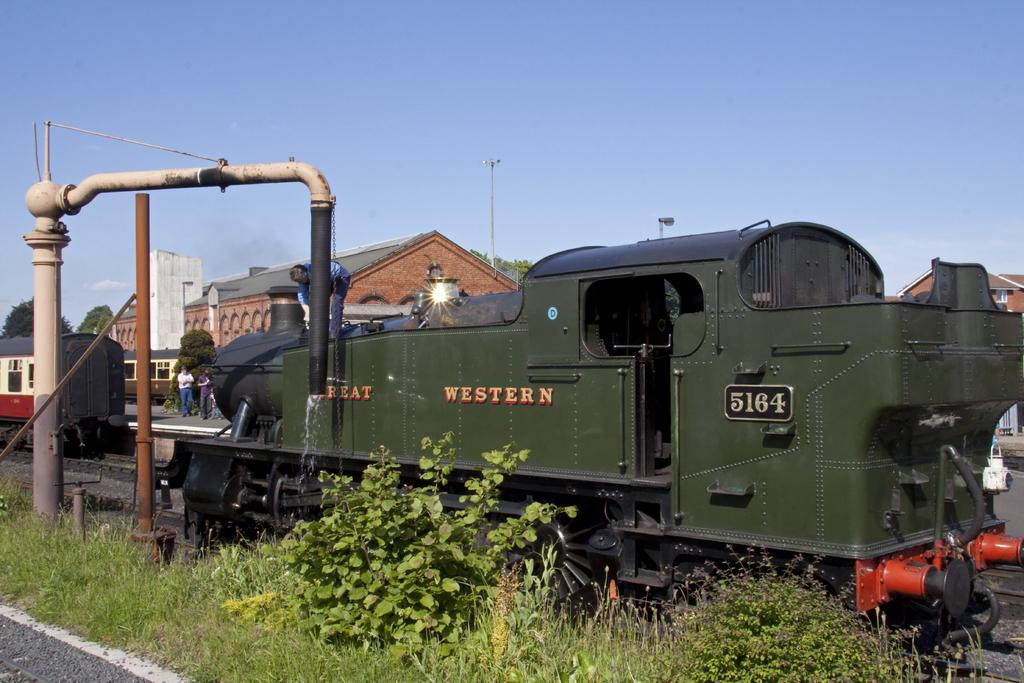What type of vehicles are on the tracks in the image? There are two trains on the tracks in the image. Can you describe the people visible in the image? There are people visible in the image, but their specific actions or characteristics are not mentioned in the facts. What type of structures can be seen in the image? There are buildings in the image. What type of vegetation is present in the image? There are plants, trees, and grass in the image. What is visible in the background of the image? The sky is visible in the background of the image. What type of health advice can be seen on the train in the image? There is no health advice visible on the trains in the image; they are simply vehicles on the tracks. Can you hear the buzzing of a bee in the image? There is no mention of a bee or any sound in the image, so it cannot be determined if a bee is buzzing or not. 